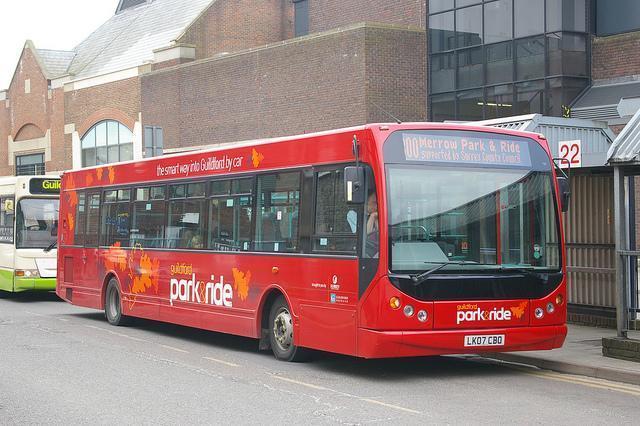How many buses are there?
Give a very brief answer. 2. 